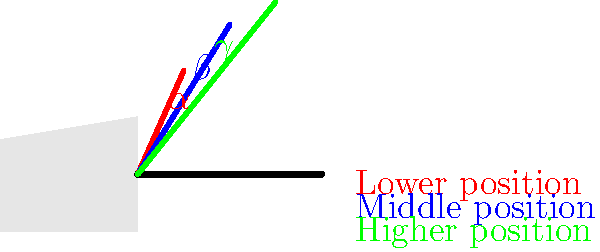As a classical guitarist, you understand the importance of proper arm positioning. The diagram shows three different arm positions relative to the guitar neck. If the angle formed between the arm and the guitar neck in the lower position (red) is 30°, and each subsequent position increases this angle by 15°, what is the sum of all three angles ($\alpha + \beta + \gamma$)? Let's approach this step-by-step:

1. We're given that the angle in the lower position (red, $\alpha$) is 30°.

2. Each subsequent position increases by 15°. So:
   - Middle position (blue, $\beta$) = $30° + 15° = 45°$
   - Higher position (green, $\gamma$) = $45° + 15° = 60°$

3. Now we have all three angles:
   $\alpha = 30°$
   $\beta = 45°$
   $\gamma = 60°$

4. The question asks for the sum of all three angles:
   $\alpha + \beta + \gamma = 30° + 45° + 60° = 135°$

This sum represents the total angular change as the arm moves from the lower to the higher position on the guitar neck. Understanding these angles is crucial for maintaining proper technique and avoiding strain during extended playing sessions.
Answer: 135° 